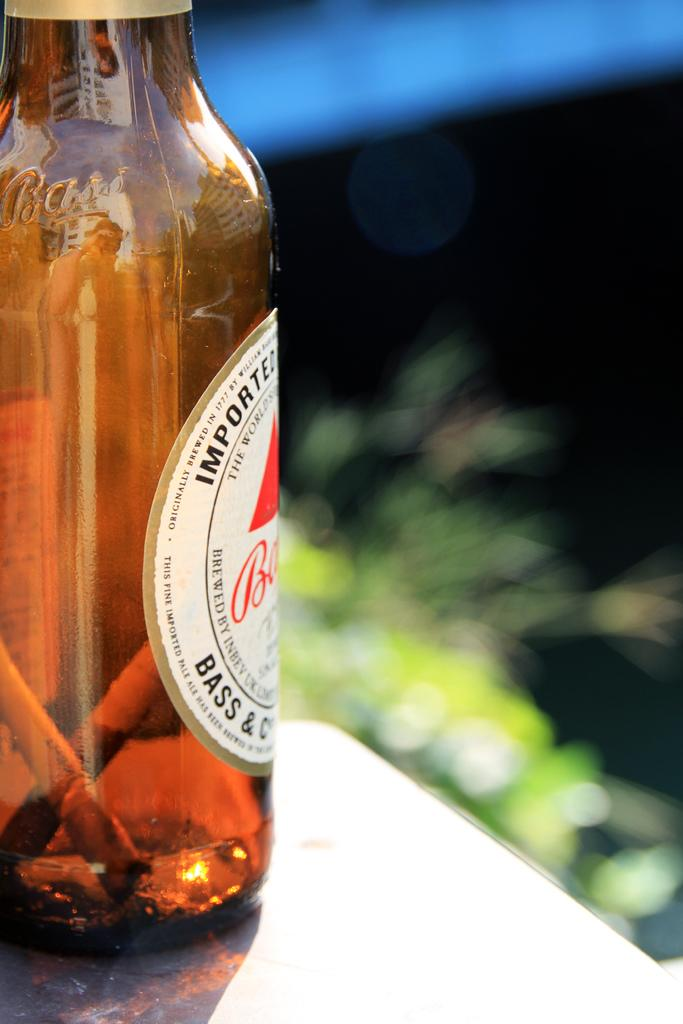<image>
Offer a succinct explanation of the picture presented. An imported Bass beer glass with two sticks in the bottle. 